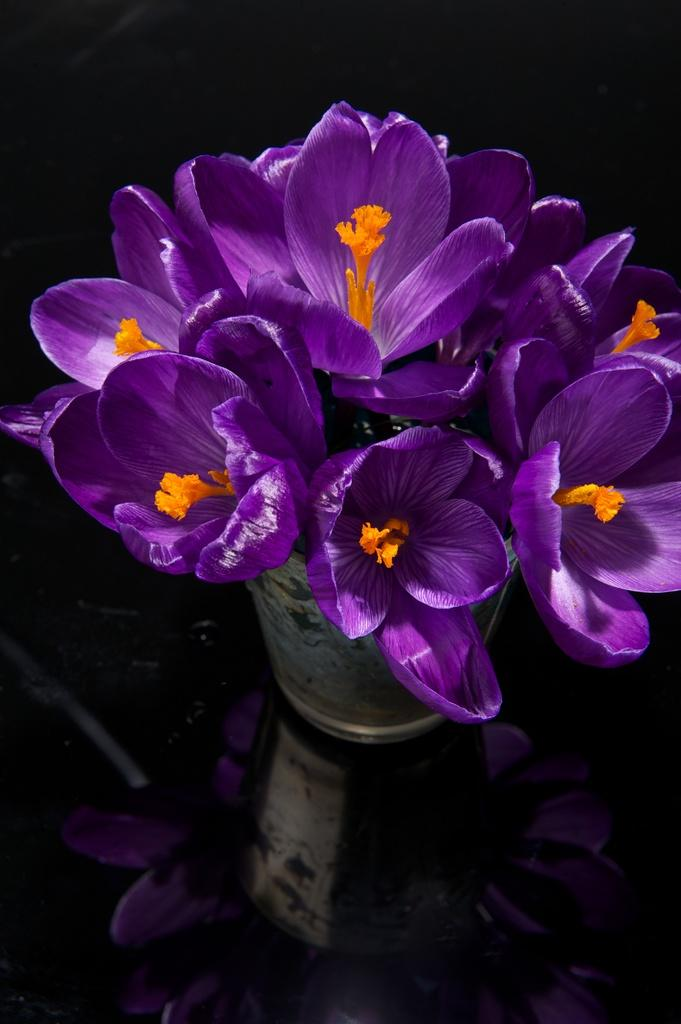What type of flowers can be seen in the image? There are purple flowers in the image. How are the flowers arranged or displayed in the image? The flowers are in a flower vase. Is there a river flowing through the image? No, there is no river present in the image. What type of sky can be seen in the image? The provided facts do not mention the sky, so it cannot be determined from the image. 